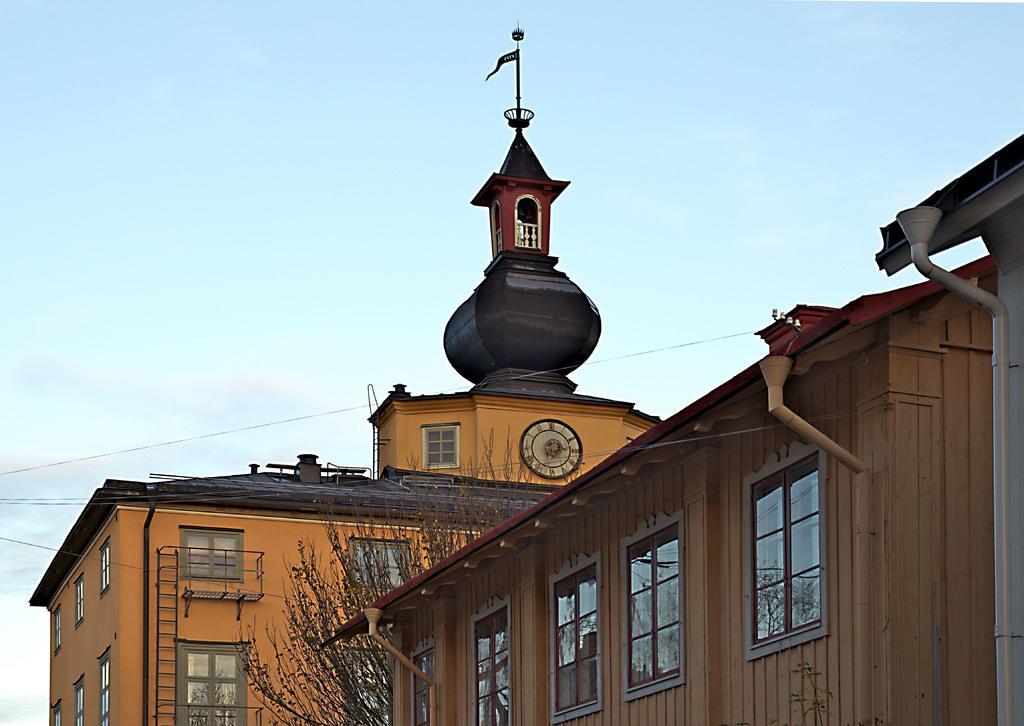Please provide a concise description of this image. In the center of the image there are buildings. At the top of the image there is sky. 